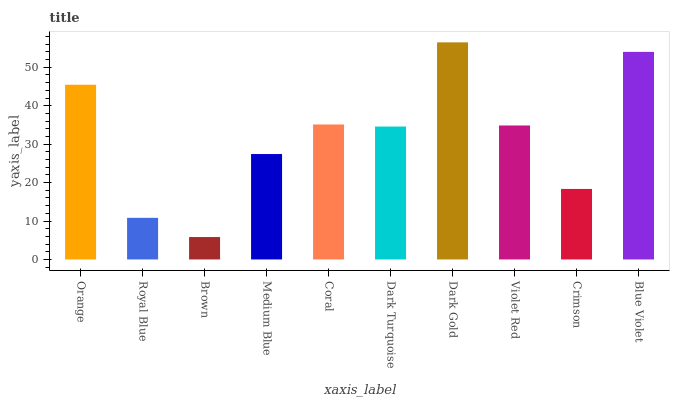Is Brown the minimum?
Answer yes or no. Yes. Is Dark Gold the maximum?
Answer yes or no. Yes. Is Royal Blue the minimum?
Answer yes or no. No. Is Royal Blue the maximum?
Answer yes or no. No. Is Orange greater than Royal Blue?
Answer yes or no. Yes. Is Royal Blue less than Orange?
Answer yes or no. Yes. Is Royal Blue greater than Orange?
Answer yes or no. No. Is Orange less than Royal Blue?
Answer yes or no. No. Is Violet Red the high median?
Answer yes or no. Yes. Is Dark Turquoise the low median?
Answer yes or no. Yes. Is Coral the high median?
Answer yes or no. No. Is Medium Blue the low median?
Answer yes or no. No. 